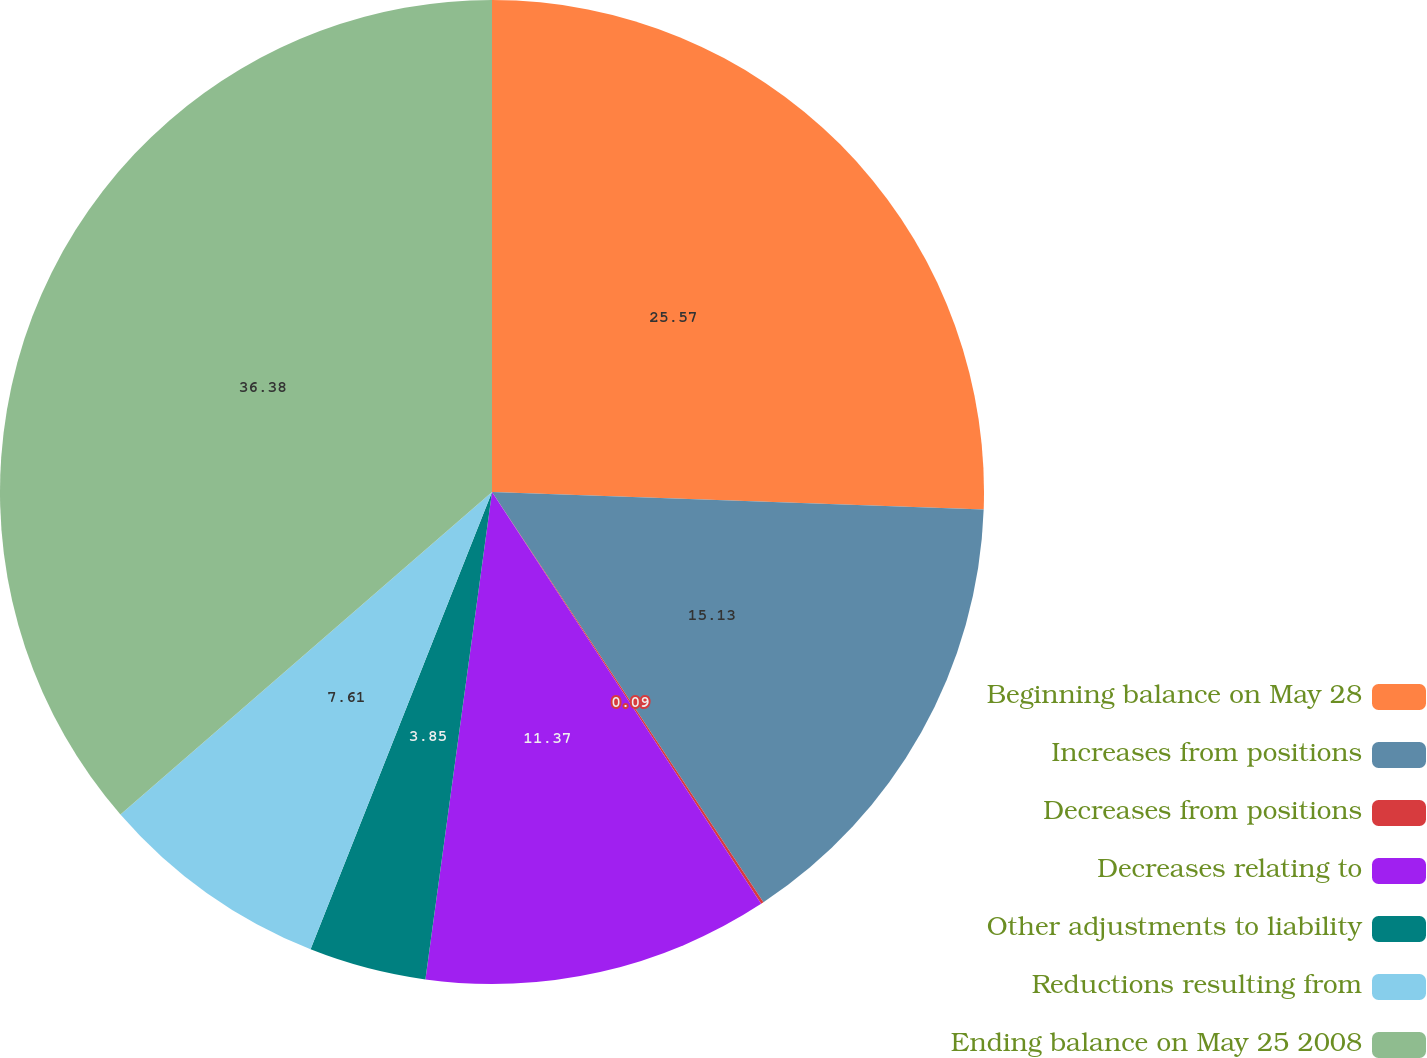Convert chart. <chart><loc_0><loc_0><loc_500><loc_500><pie_chart><fcel>Beginning balance on May 28<fcel>Increases from positions<fcel>Decreases from positions<fcel>Decreases relating to<fcel>Other adjustments to liability<fcel>Reductions resulting from<fcel>Ending balance on May 25 2008<nl><fcel>25.56%<fcel>15.13%<fcel>0.09%<fcel>11.37%<fcel>3.85%<fcel>7.61%<fcel>36.37%<nl></chart> 